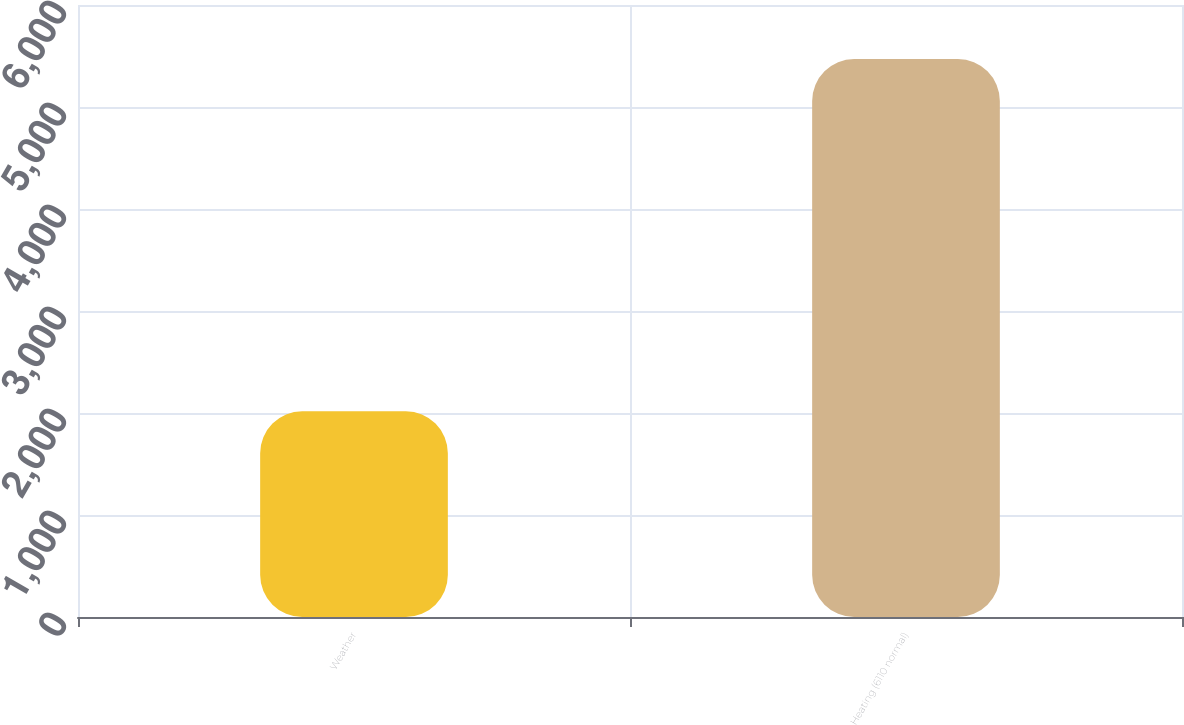Convert chart to OTSL. <chart><loc_0><loc_0><loc_500><loc_500><bar_chart><fcel>Weather<fcel>Heating (6110 normal)<nl><fcel>2017<fcel>5470<nl></chart> 